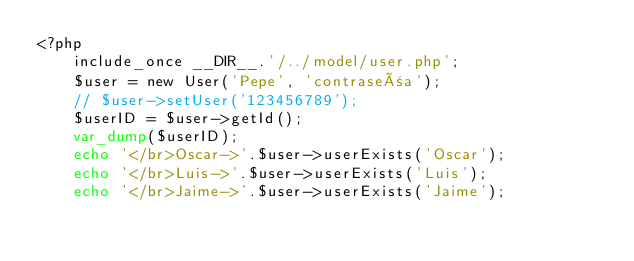<code> <loc_0><loc_0><loc_500><loc_500><_PHP_><?php 
    include_once __DIR__.'/../model/user.php'; 
    $user = new User('Pepe', 'contraseña');
    // $user->setUser('123456789');
    $userID = $user->getId();
    var_dump($userID);
    echo '</br>Oscar->'.$user->userExists('Oscar');
    echo '</br>Luis->'.$user->userExists('Luis');
    echo '</br>Jaime->'.$user->userExists('Jaime');

</code> 